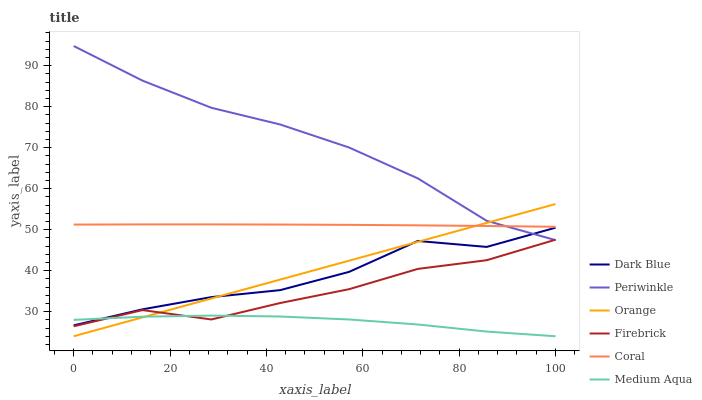Does Medium Aqua have the minimum area under the curve?
Answer yes or no. Yes. Does Periwinkle have the maximum area under the curve?
Answer yes or no. Yes. Does Dark Blue have the minimum area under the curve?
Answer yes or no. No. Does Dark Blue have the maximum area under the curve?
Answer yes or no. No. Is Orange the smoothest?
Answer yes or no. Yes. Is Dark Blue the roughest?
Answer yes or no. Yes. Is Periwinkle the smoothest?
Answer yes or no. No. Is Periwinkle the roughest?
Answer yes or no. No. Does Dark Blue have the lowest value?
Answer yes or no. No. Does Dark Blue have the highest value?
Answer yes or no. No. Is Medium Aqua less than Coral?
Answer yes or no. Yes. Is Coral greater than Medium Aqua?
Answer yes or no. Yes. Does Medium Aqua intersect Coral?
Answer yes or no. No. 